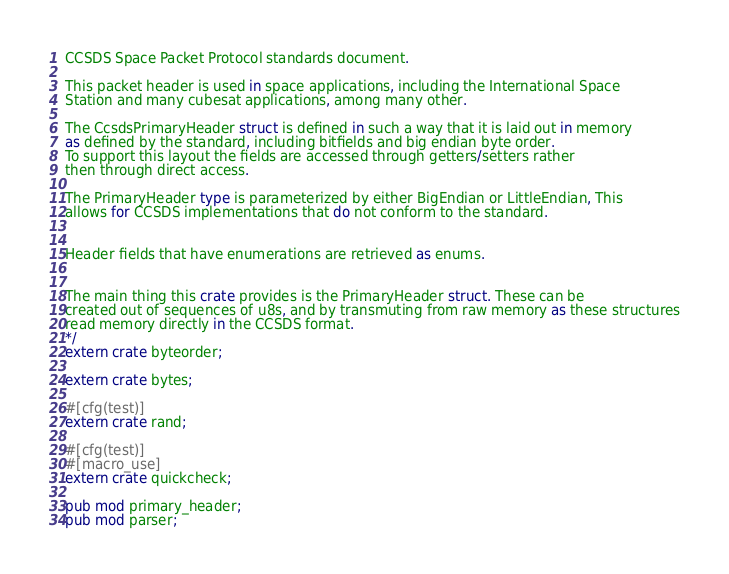Convert code to text. <code><loc_0><loc_0><loc_500><loc_500><_Rust_>CCSDS Space Packet Protocol standards document.

This packet header is used in space applications, including the International Space
Station and many cubesat applications, among many other.

The CcsdsPrimaryHeader struct is defined in such a way that it is laid out in memory
as defined by the standard, including bitfields and big endian byte order.
To support this layout the fields are accessed through getters/setters rather
then through direct access.

The PrimaryHeader type is parameterized by either BigEndian or LittleEndian, This
allows for CCSDS implementations that do not conform to the standard.


Header fields that have enumerations are retrieved as enums.


The main thing this crate provides is the PrimaryHeader struct. These can be
created out of sequences of u8s, and by transmuting from raw memory as these structures
read memory directly in the CCSDS format.
*/
extern crate byteorder;

extern crate bytes;

#[cfg(test)]
extern crate rand;

#[cfg(test)]
#[macro_use]
extern crate quickcheck;

pub mod primary_header;
pub mod parser;

</code> 